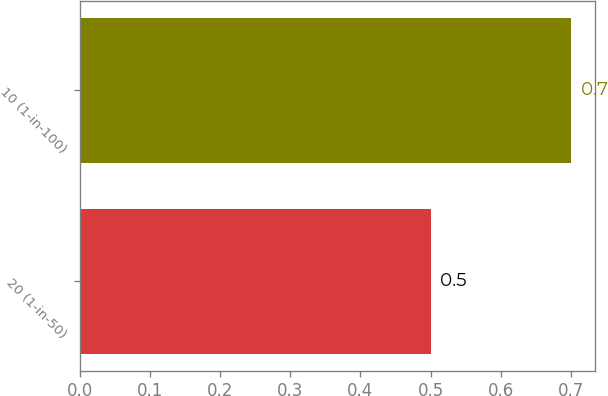Convert chart to OTSL. <chart><loc_0><loc_0><loc_500><loc_500><bar_chart><fcel>20 (1-in-50)<fcel>10 (1-in-100)<nl><fcel>0.5<fcel>0.7<nl></chart> 